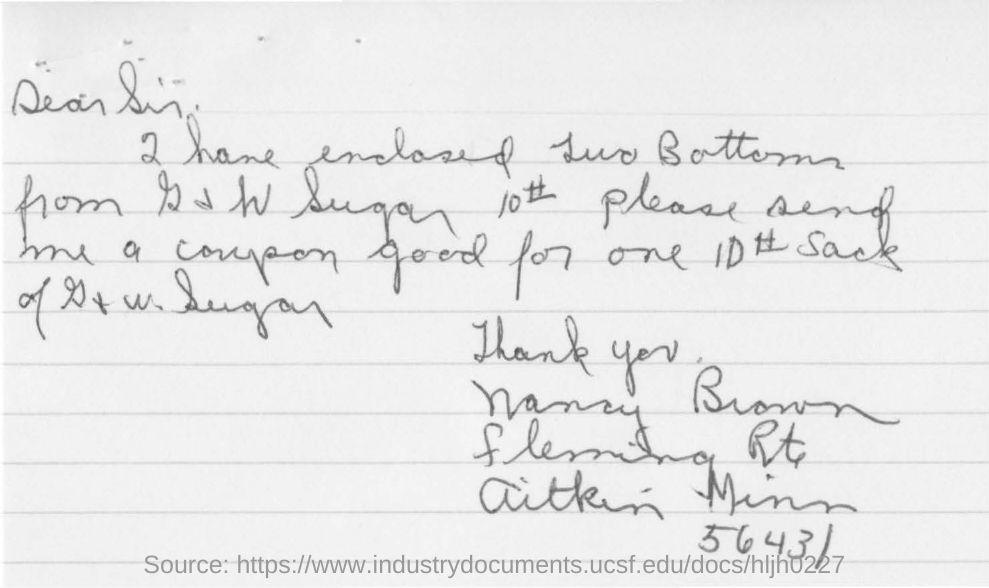What is the ZIP code?
Offer a terse response. 56431. 